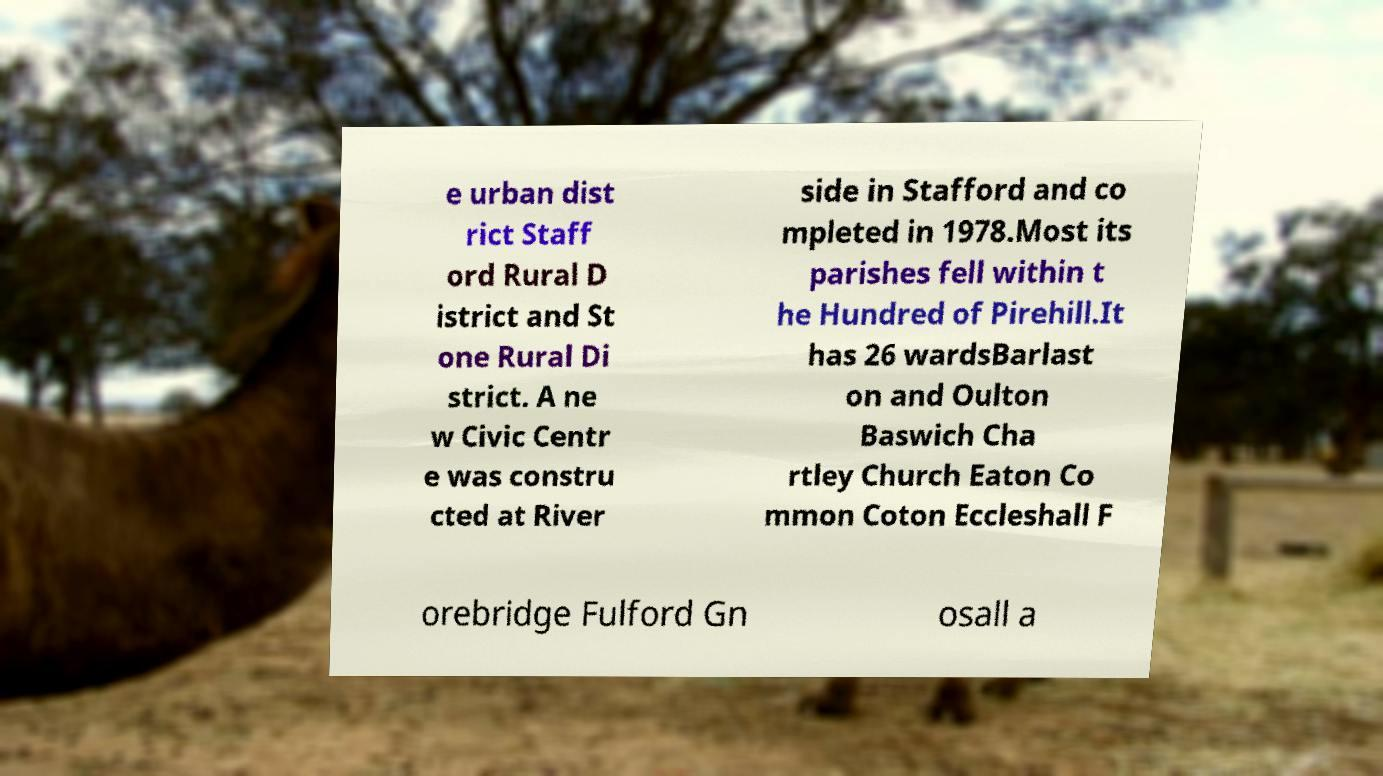Can you read and provide the text displayed in the image?This photo seems to have some interesting text. Can you extract and type it out for me? e urban dist rict Staff ord Rural D istrict and St one Rural Di strict. A ne w Civic Centr e was constru cted at River side in Stafford and co mpleted in 1978.Most its parishes fell within t he Hundred of Pirehill.It has 26 wardsBarlast on and Oulton Baswich Cha rtley Church Eaton Co mmon Coton Eccleshall F orebridge Fulford Gn osall a 